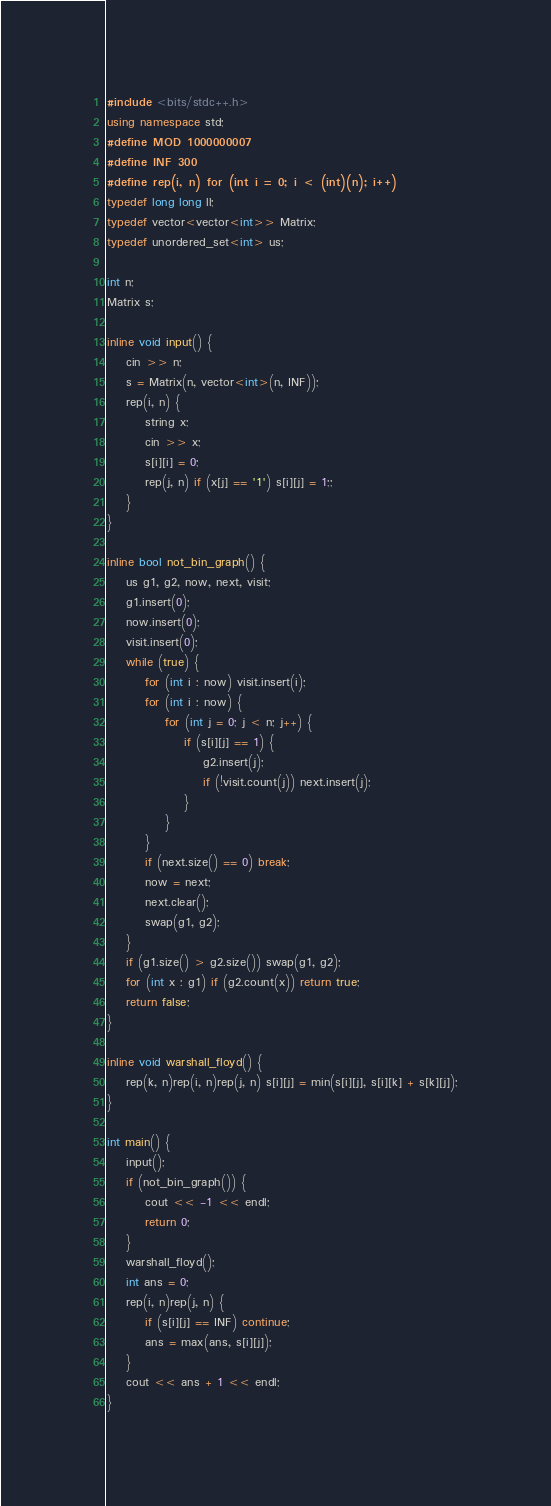<code> <loc_0><loc_0><loc_500><loc_500><_C++_>#include <bits/stdc++.h>
using namespace std;
#define MOD 1000000007
#define INF 300
#define rep(i, n) for (int i = 0; i < (int)(n); i++)
typedef long long ll;
typedef vector<vector<int>> Matrix;
typedef unordered_set<int> us;

int n;
Matrix s;

inline void input() {
    cin >> n;
    s = Matrix(n, vector<int>(n, INF));
    rep(i, n) {
        string x;
        cin >> x;
        s[i][i] = 0;
        rep(j, n) if (x[j] == '1') s[i][j] = 1;;
    }
}

inline bool not_bin_graph() {
    us g1, g2, now, next, visit;
    g1.insert(0);
    now.insert(0);
    visit.insert(0);
    while (true) {
        for (int i : now) visit.insert(i);
        for (int i : now) {
            for (int j = 0; j < n; j++) {
                if (s[i][j] == 1) {
                    g2.insert(j);
                    if (!visit.count(j)) next.insert(j);
                }
            }
        }
        if (next.size() == 0) break; 
        now = next;
        next.clear();
        swap(g1, g2);
    }
    if (g1.size() > g2.size()) swap(g1, g2);
    for (int x : g1) if (g2.count(x)) return true;
    return false;
}

inline void warshall_floyd() {
    rep(k, n)rep(i, n)rep(j, n) s[i][j] = min(s[i][j], s[i][k] + s[k][j]);
}

int main() {
    input();
    if (not_bin_graph()) {
        cout << -1 << endl;
        return 0;
    }
    warshall_floyd();
    int ans = 0;
    rep(i, n)rep(j, n) {
        if (s[i][j] == INF) continue;
        ans = max(ans, s[i][j]);
    }
    cout << ans + 1 << endl;
}
</code> 